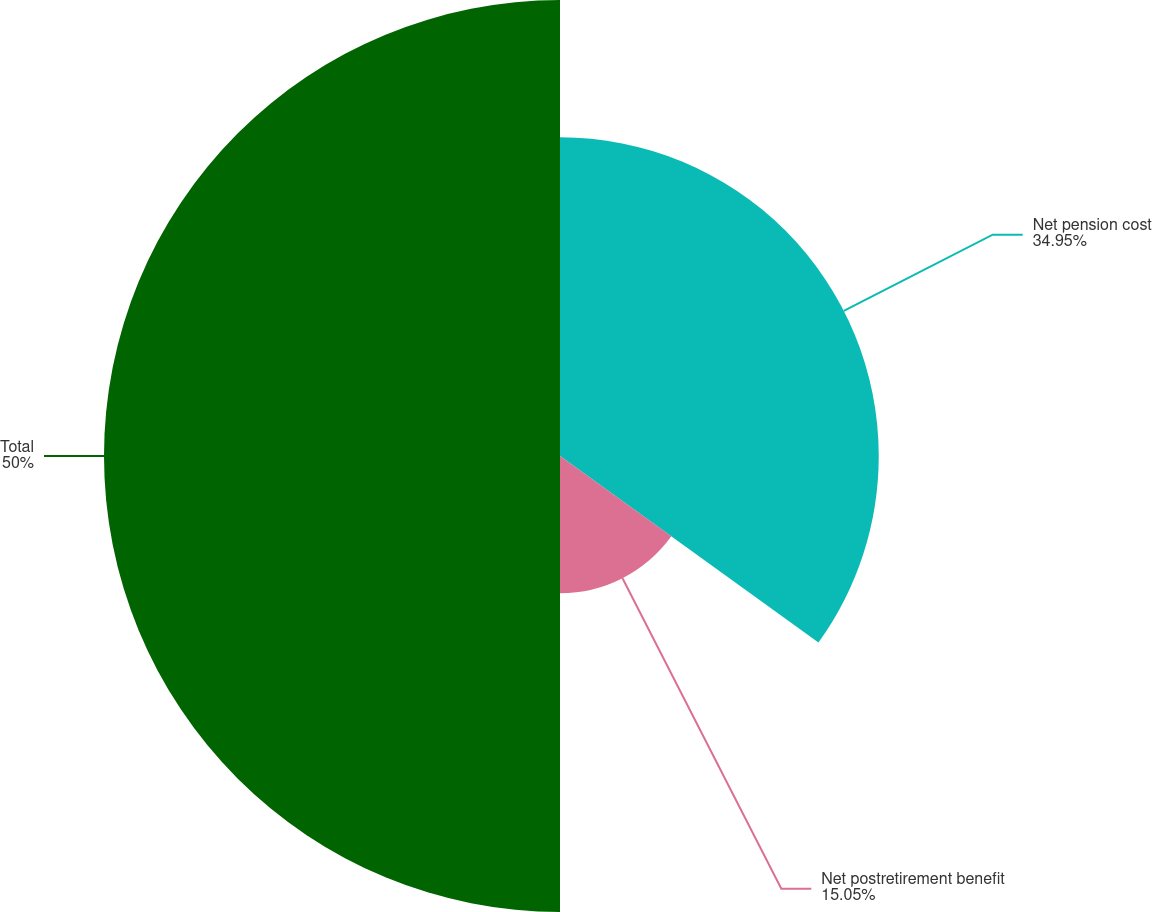Convert chart to OTSL. <chart><loc_0><loc_0><loc_500><loc_500><pie_chart><fcel>Net pension cost<fcel>Net postretirement benefit<fcel>Total<nl><fcel>34.95%<fcel>15.05%<fcel>50.0%<nl></chart> 